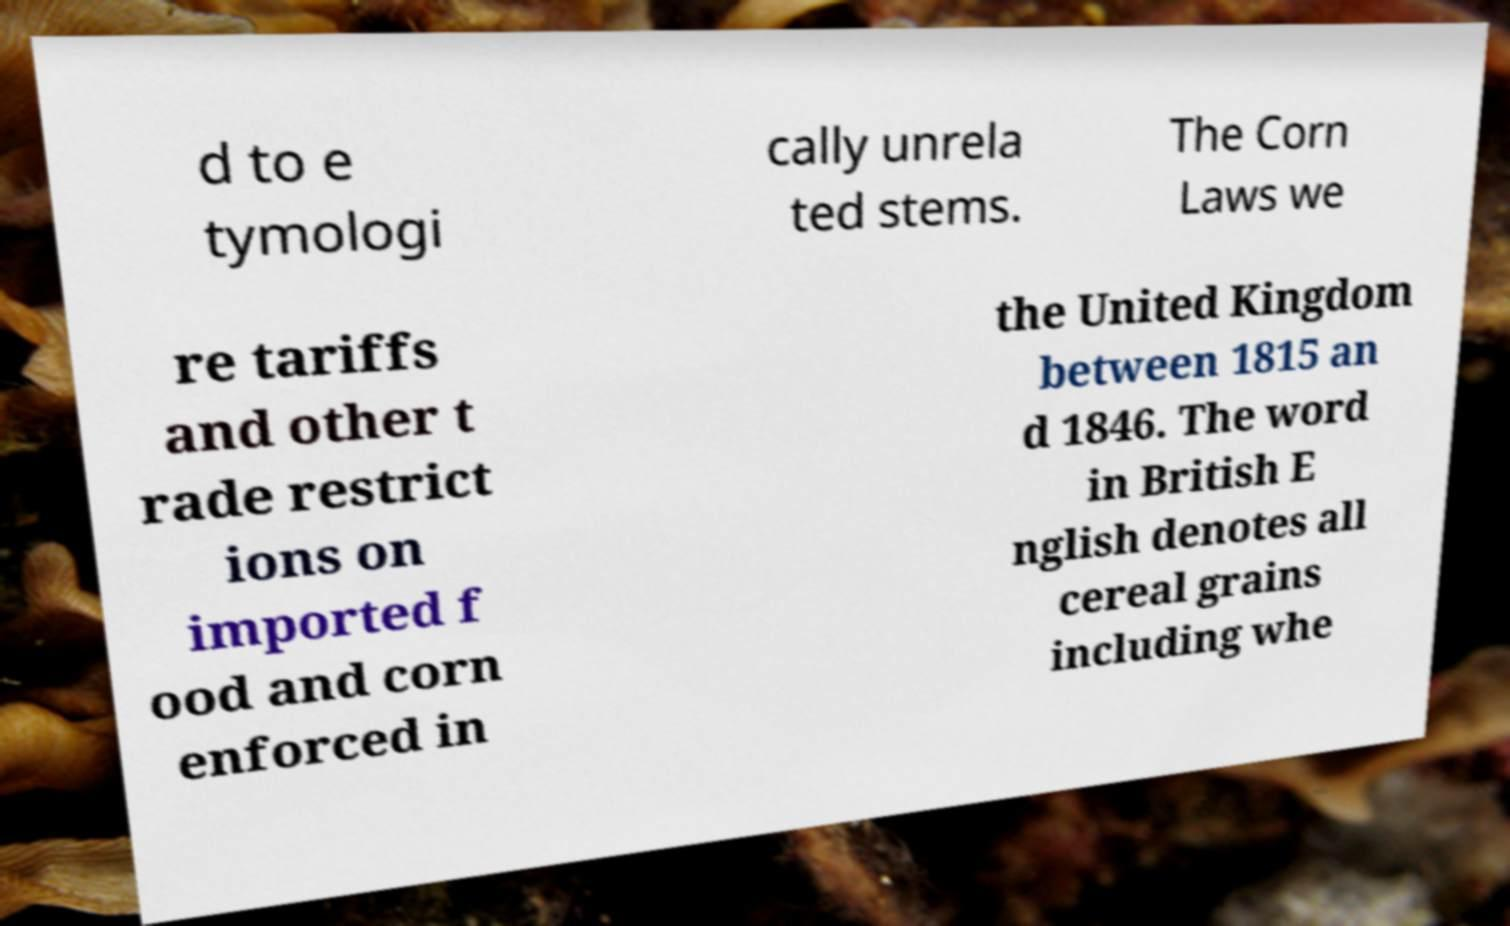What messages or text are displayed in this image? I need them in a readable, typed format. d to e tymologi cally unrela ted stems. The Corn Laws we re tariffs and other t rade restrict ions on imported f ood and corn enforced in the United Kingdom between 1815 an d 1846. The word in British E nglish denotes all cereal grains including whe 